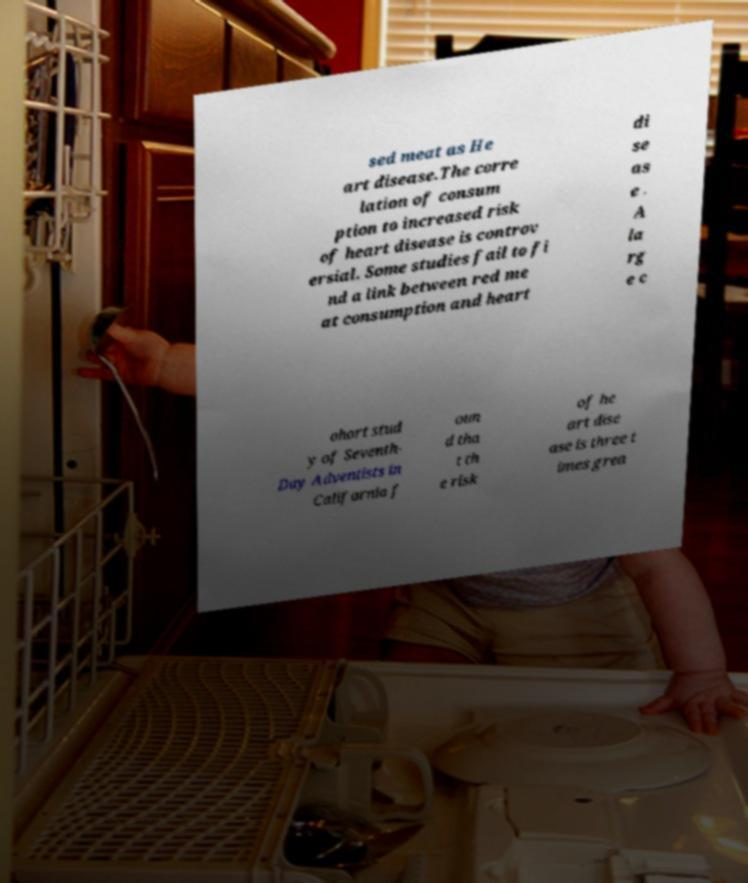Please identify and transcribe the text found in this image. sed meat as He art disease.The corre lation of consum ption to increased risk of heart disease is controv ersial. Some studies fail to fi nd a link between red me at consumption and heart di se as e . A la rg e c ohort stud y of Seventh- Day Adventists in California f oun d tha t th e risk of he art dise ase is three t imes grea 